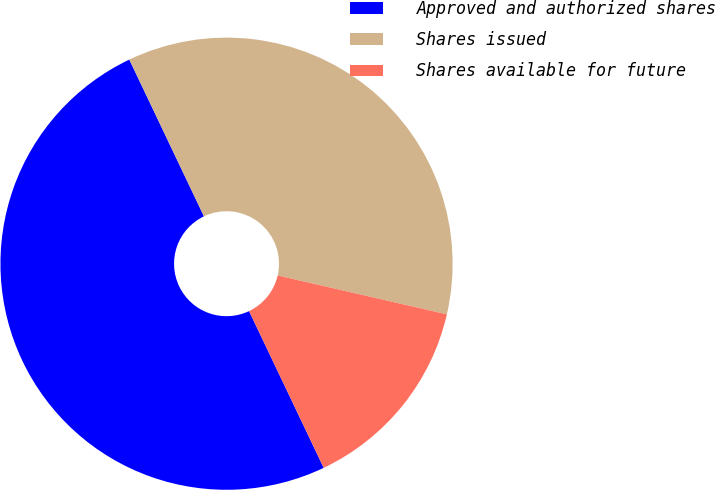Convert chart to OTSL. <chart><loc_0><loc_0><loc_500><loc_500><pie_chart><fcel>Approved and authorized shares<fcel>Shares issued<fcel>Shares available for future<nl><fcel>50.0%<fcel>35.67%<fcel>14.33%<nl></chart> 